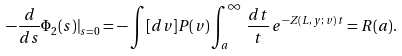Convert formula to latex. <formula><loc_0><loc_0><loc_500><loc_500>- \frac { d } { d s } \Phi _ { 2 } ( s ) | _ { s = 0 } = - \int [ d v ] P ( v ) \int _ { a } ^ { \infty } \, \frac { d t } { t } \, e ^ { - Z ( L , \, y ; \, v ) \, t } = R ( a ) .</formula> 